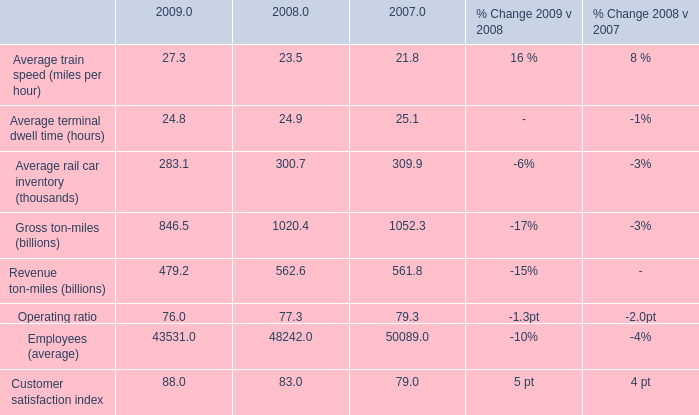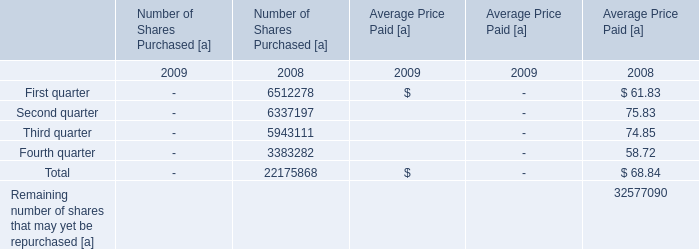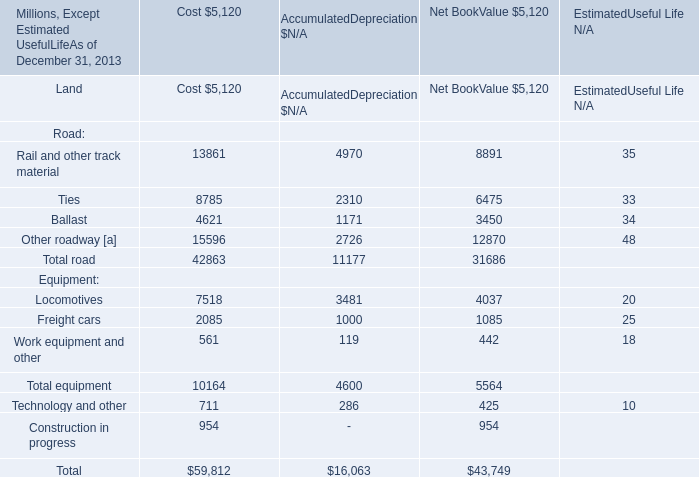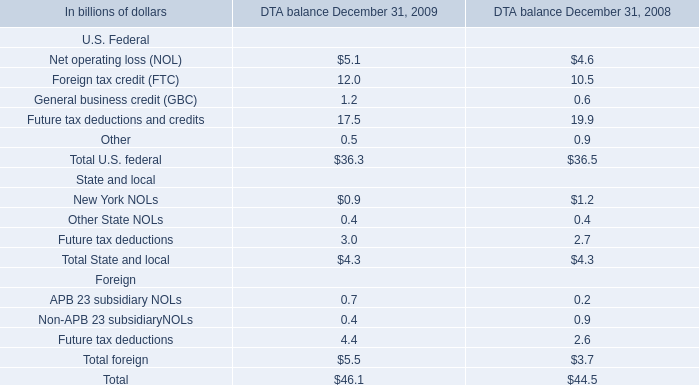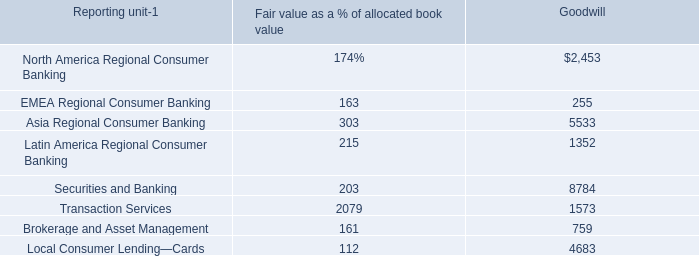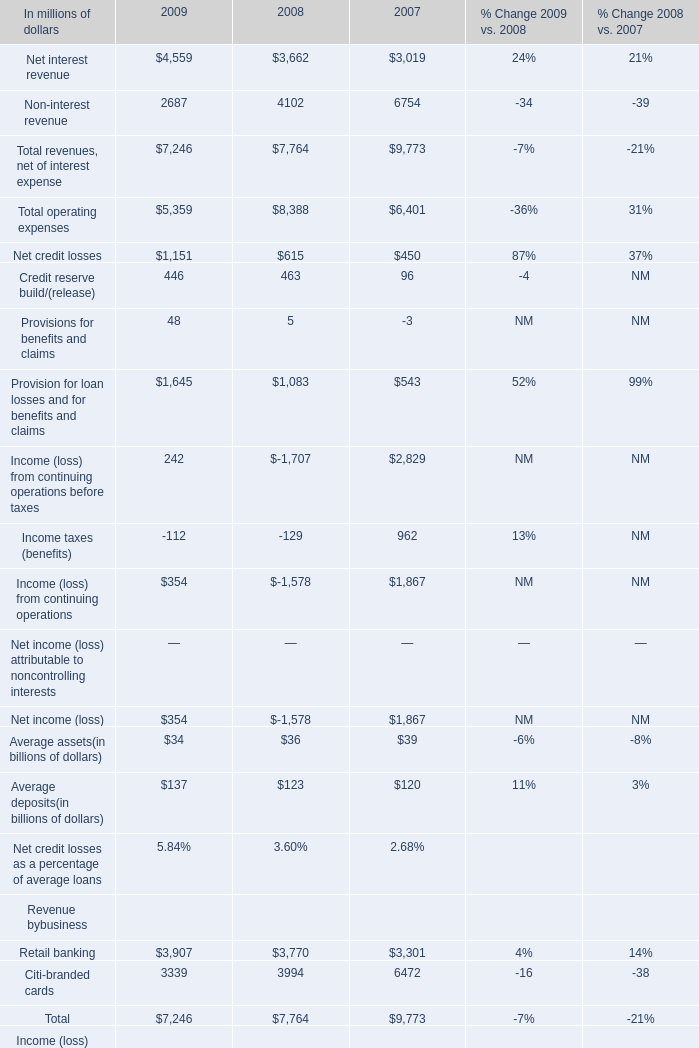What is the sum of North America Regional Consumer Banking of Goodwill, Ties of data 2 [EMPTY].2, and Total operating expenses of 2009 ? 
Computations: ((2453.0 + 6475.0) + 5359.0)
Answer: 14287.0. 